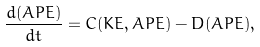<formula> <loc_0><loc_0><loc_500><loc_500>\frac { d ( A P E ) } { d t } = C ( K E , A P E ) - D ( A P E ) ,</formula> 